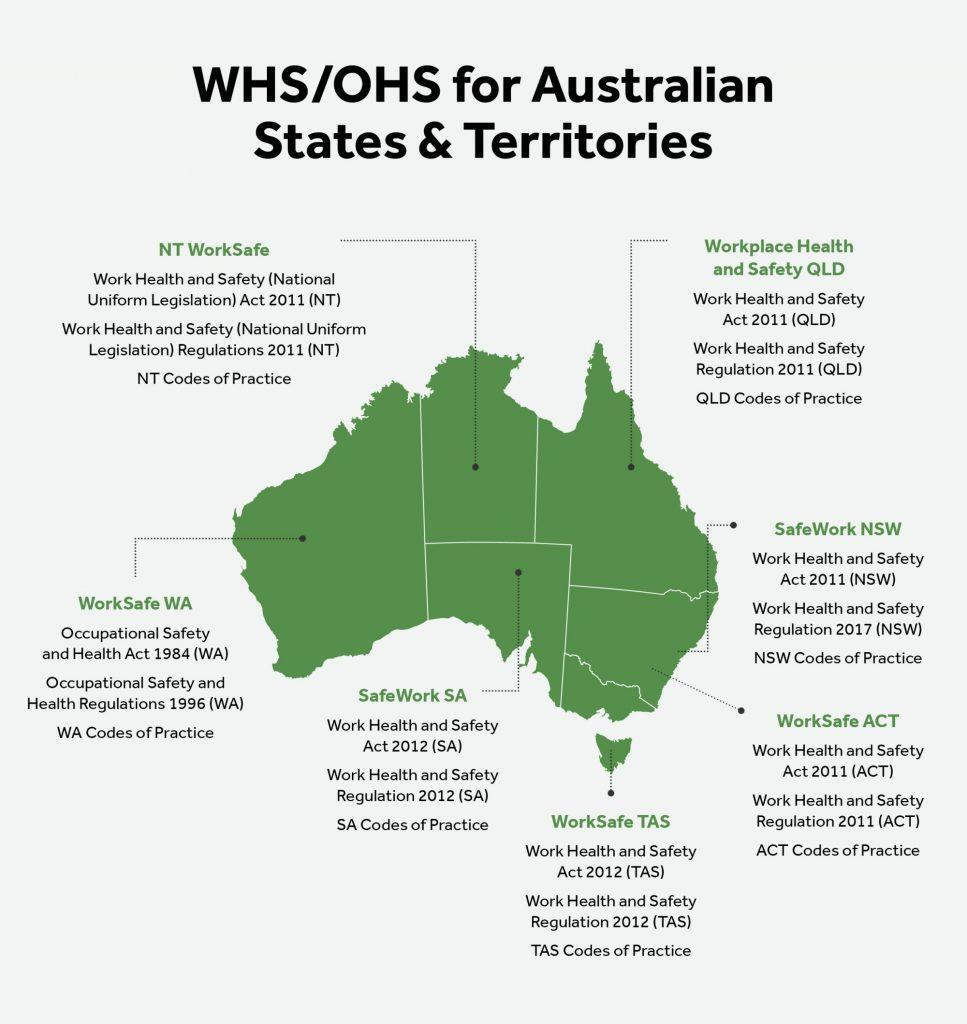How many WHS/ OHS regulations are listed under the WorkSafe ACT?
Answer the question with a short phrase. 3 How many WHS / OHS are listed for all the Australian States & Territories ? 7 